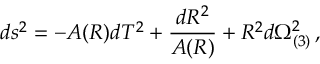<formula> <loc_0><loc_0><loc_500><loc_500>d s ^ { 2 } = - A ( R ) d T ^ { 2 } + { \frac { d R ^ { 2 } } { A ( R ) } } + R ^ { 2 } d \Omega _ { ( 3 ) } ^ { 2 } \, ,</formula> 